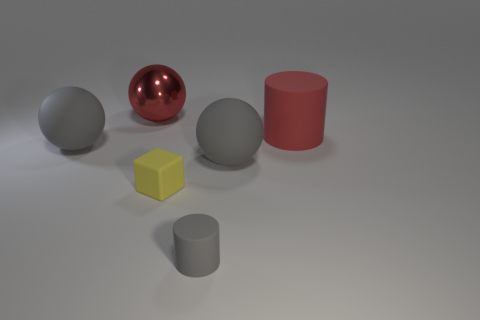Subtract all red balls. How many balls are left? 2 Subtract all blocks. How many objects are left? 5 Subtract 1 cubes. How many cubes are left? 0 Add 3 small matte objects. How many objects exist? 9 Subtract all red spheres. How many spheres are left? 2 Subtract all gray matte objects. Subtract all gray things. How many objects are left? 0 Add 2 large red cylinders. How many large red cylinders are left? 3 Add 5 small green objects. How many small green objects exist? 5 Subtract 0 cyan balls. How many objects are left? 6 Subtract all cyan cubes. Subtract all gray balls. How many cubes are left? 1 